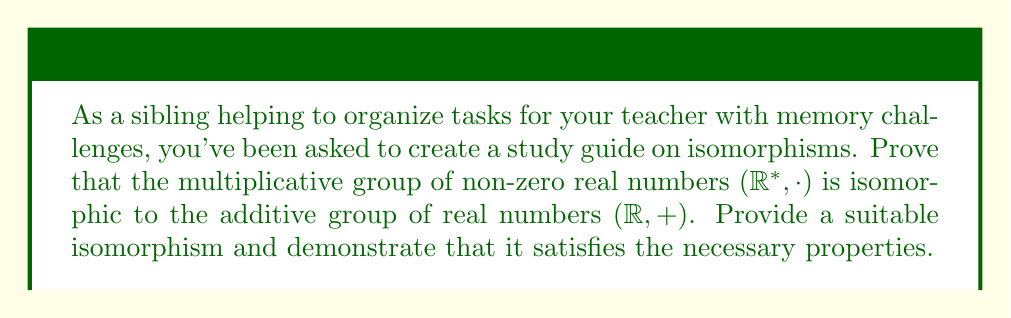What is the answer to this math problem? To prove that $({\mathbb{R}}^*, \cdot)$ is isomorphic to $({\mathbb{R}}, +)$, we need to find a bijective function $f: {\mathbb{R}}^* \to {\mathbb{R}}$ that preserves the group operation. Let's follow these steps:

1) Define the function:
   Let $f: {\mathbb{R}}^* \to {\mathbb{R}}$ be defined as $f(x) = \ln(x)$ for $x > 0$ and $f(x) = -\ln(-x)$ for $x < 0$.

2) Prove that $f$ is bijective:
   - $f$ is injective: If $f(a) = f(b)$, then either $\ln(a) = \ln(b)$ or $-\ln(-a) = -\ln(-b)$, which implies $a = b$.
   - $f$ is surjective: For any $y \in {\mathbb{R}}$, there exists an $x \in {\mathbb{R}}^*$ such that $f(x) = y$. If $y \geq 0$, then $x = e^y > 0$. If $y < 0$, then $x = -e^{-y} < 0$.

3) Prove that $f$ preserves the group operation:
   We need to show that $f(ab) = f(a) + f(b)$ for all $a, b \in {\mathbb{R}}^*$.

   Case 1: If $a > 0$ and $b > 0$:
   $$f(ab) = \ln(ab) = \ln(a) + \ln(b) = f(a) + f(b)$$

   Case 2: If $a < 0$ and $b < 0$:
   $$f(ab) = \ln(ab) = \ln((-a)(-b)) = \ln(-a) + \ln(-b) = -f(a) - f(b) = f(a) + f(b)$$

   Case 3: If $a > 0$ and $b < 0$ (or vice versa):
   $$f(ab) = -\ln(-(ab)) = -\ln(a(-b)) = -(\ln(a) + \ln(-b)) = -\ln(a) + \ln(-b) = f(a) + f(b)$$

Therefore, $f$ is an isomorphism between $({\mathbb{R}}^*, \cdot)$ and $({\mathbb{R}}, +)$.
Answer: The isomorphism $f: {\mathbb{R}}^* \to {\mathbb{R}}$ is defined as:

$$f(x) = \begin{cases}
\ln(x) & \text{if } x > 0 \\
-\ln(-x) & \text{if } x < 0
\end{cases}$$

This function is bijective and preserves the group operation, thus proving that $({\mathbb{R}}^*, \cdot)$ is isomorphic to $({\mathbb{R}}, +)$. 